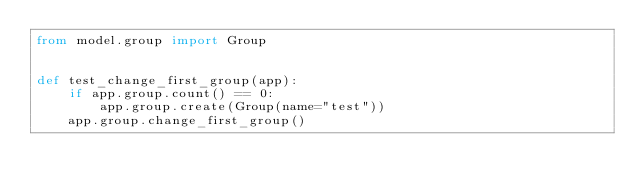<code> <loc_0><loc_0><loc_500><loc_500><_Python_>from model.group import Group


def test_change_first_group(app):
    if app.group.count() == 0:
        app.group.create(Group(name="test"))
    app.group.change_first_group()

</code> 